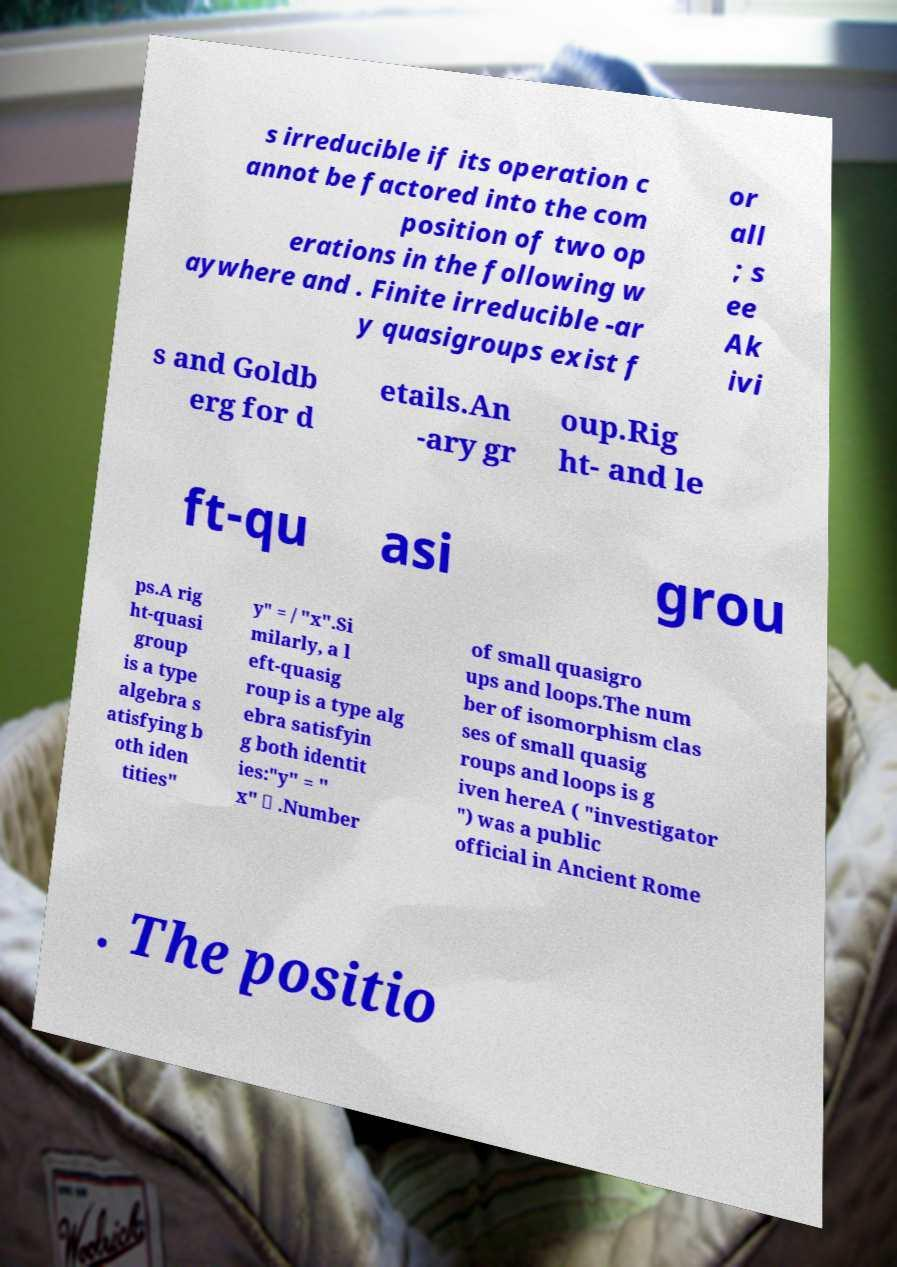Can you accurately transcribe the text from the provided image for me? s irreducible if its operation c annot be factored into the com position of two op erations in the following w aywhere and . Finite irreducible -ar y quasigroups exist f or all ; s ee Ak ivi s and Goldb erg for d etails.An -ary gr oup.Rig ht- and le ft-qu asi grou ps.A rig ht-quasi group is a type algebra s atisfying b oth iden tities" y" = / "x".Si milarly, a l eft-quasig roup is a type alg ebra satisfyin g both identit ies:"y" = " x" \ .Number of small quasigro ups and loops.The num ber of isomorphism clas ses of small quasig roups and loops is g iven hereA ( "investigator ") was a public official in Ancient Rome . The positio 